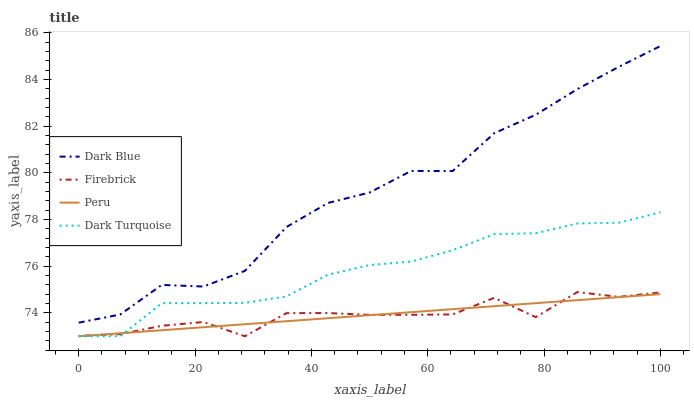Does Peru have the minimum area under the curve?
Answer yes or no. Yes. Does Dark Blue have the maximum area under the curve?
Answer yes or no. Yes. Does Firebrick have the minimum area under the curve?
Answer yes or no. No. Does Firebrick have the maximum area under the curve?
Answer yes or no. No. Is Peru the smoothest?
Answer yes or no. Yes. Is Dark Blue the roughest?
Answer yes or no. Yes. Is Firebrick the smoothest?
Answer yes or no. No. Is Firebrick the roughest?
Answer yes or no. No. Does Firebrick have the lowest value?
Answer yes or no. Yes. Does Dark Blue have the highest value?
Answer yes or no. Yes. Does Firebrick have the highest value?
Answer yes or no. No. Is Dark Turquoise less than Dark Blue?
Answer yes or no. Yes. Is Dark Blue greater than Peru?
Answer yes or no. Yes. Does Dark Turquoise intersect Peru?
Answer yes or no. Yes. Is Dark Turquoise less than Peru?
Answer yes or no. No. Is Dark Turquoise greater than Peru?
Answer yes or no. No. Does Dark Turquoise intersect Dark Blue?
Answer yes or no. No. 